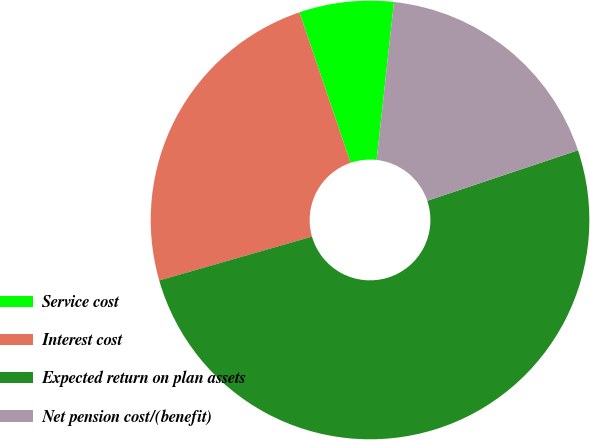Convert chart. <chart><loc_0><loc_0><loc_500><loc_500><pie_chart><fcel>Service cost<fcel>Interest cost<fcel>Expected return on plan assets<fcel>Net pension cost/(benefit)<nl><fcel>6.96%<fcel>24.23%<fcel>50.7%<fcel>18.11%<nl></chart> 